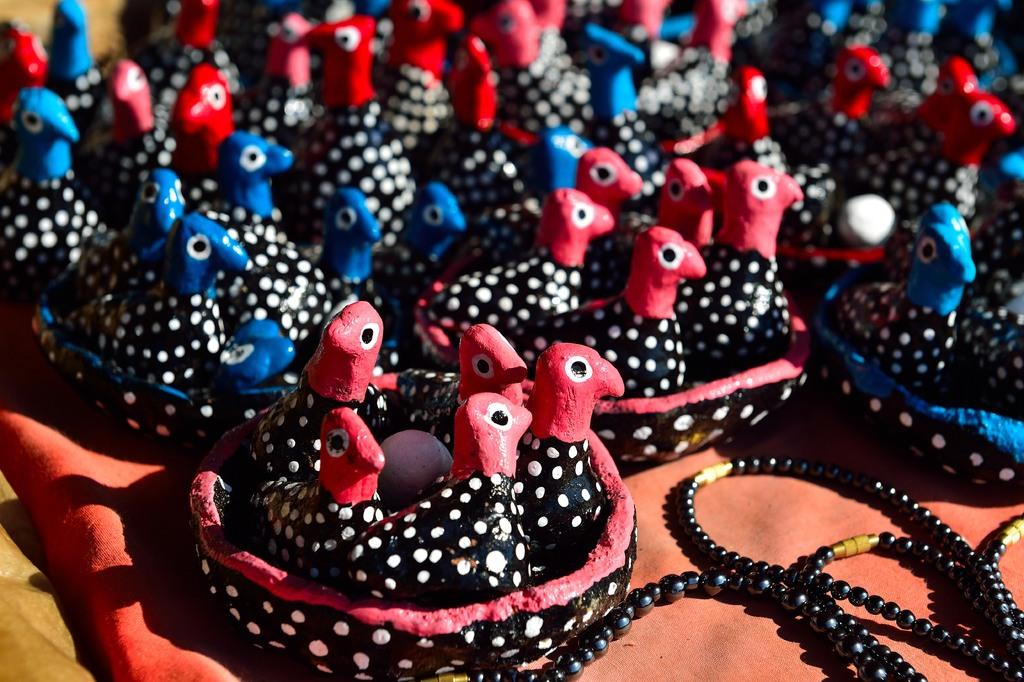What types of objects can be seen in the image? There are toys and pearls in the image. Can you describe the toys in the image? The toys in the image are not specified, but they are present. What are the pearls used for in the image? The purpose of the pearls in the image is not mentioned, but they are present. How much dirt is visible in the image? There is no dirt present in the image; it features toys and pearls. 